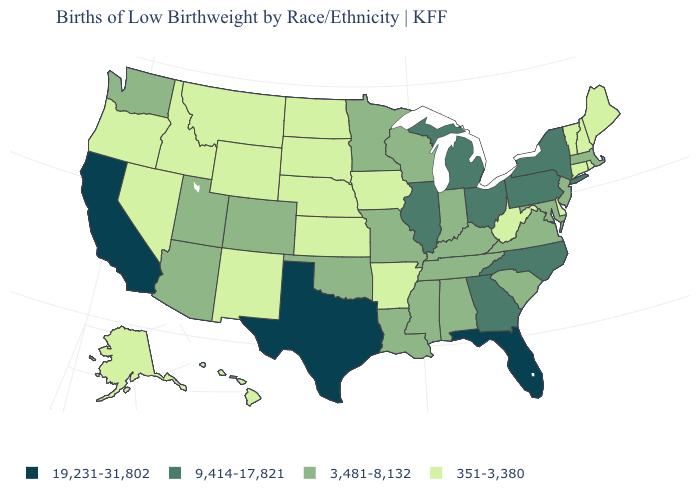Among the states that border Pennsylvania , does New York have the highest value?
Quick response, please. Yes. What is the highest value in the West ?
Keep it brief. 19,231-31,802. Among the states that border New Hampshire , which have the highest value?
Keep it brief. Massachusetts. Name the states that have a value in the range 19,231-31,802?
Give a very brief answer. California, Florida, Texas. What is the highest value in the West ?
Keep it brief. 19,231-31,802. What is the highest value in states that border New York?
Answer briefly. 9,414-17,821. Among the states that border Maine , which have the highest value?
Short answer required. New Hampshire. Among the states that border West Virginia , does Maryland have the lowest value?
Concise answer only. Yes. What is the value of Alaska?
Short answer required. 351-3,380. Among the states that border Oklahoma , does Texas have the highest value?
Keep it brief. Yes. Among the states that border Virginia , does West Virginia have the lowest value?
Answer briefly. Yes. What is the lowest value in states that border Alabama?
Short answer required. 3,481-8,132. What is the value of Maine?
Keep it brief. 351-3,380. Which states hav the highest value in the Northeast?
Write a very short answer. New York, Pennsylvania. Does Florida have the highest value in the South?
Quick response, please. Yes. 